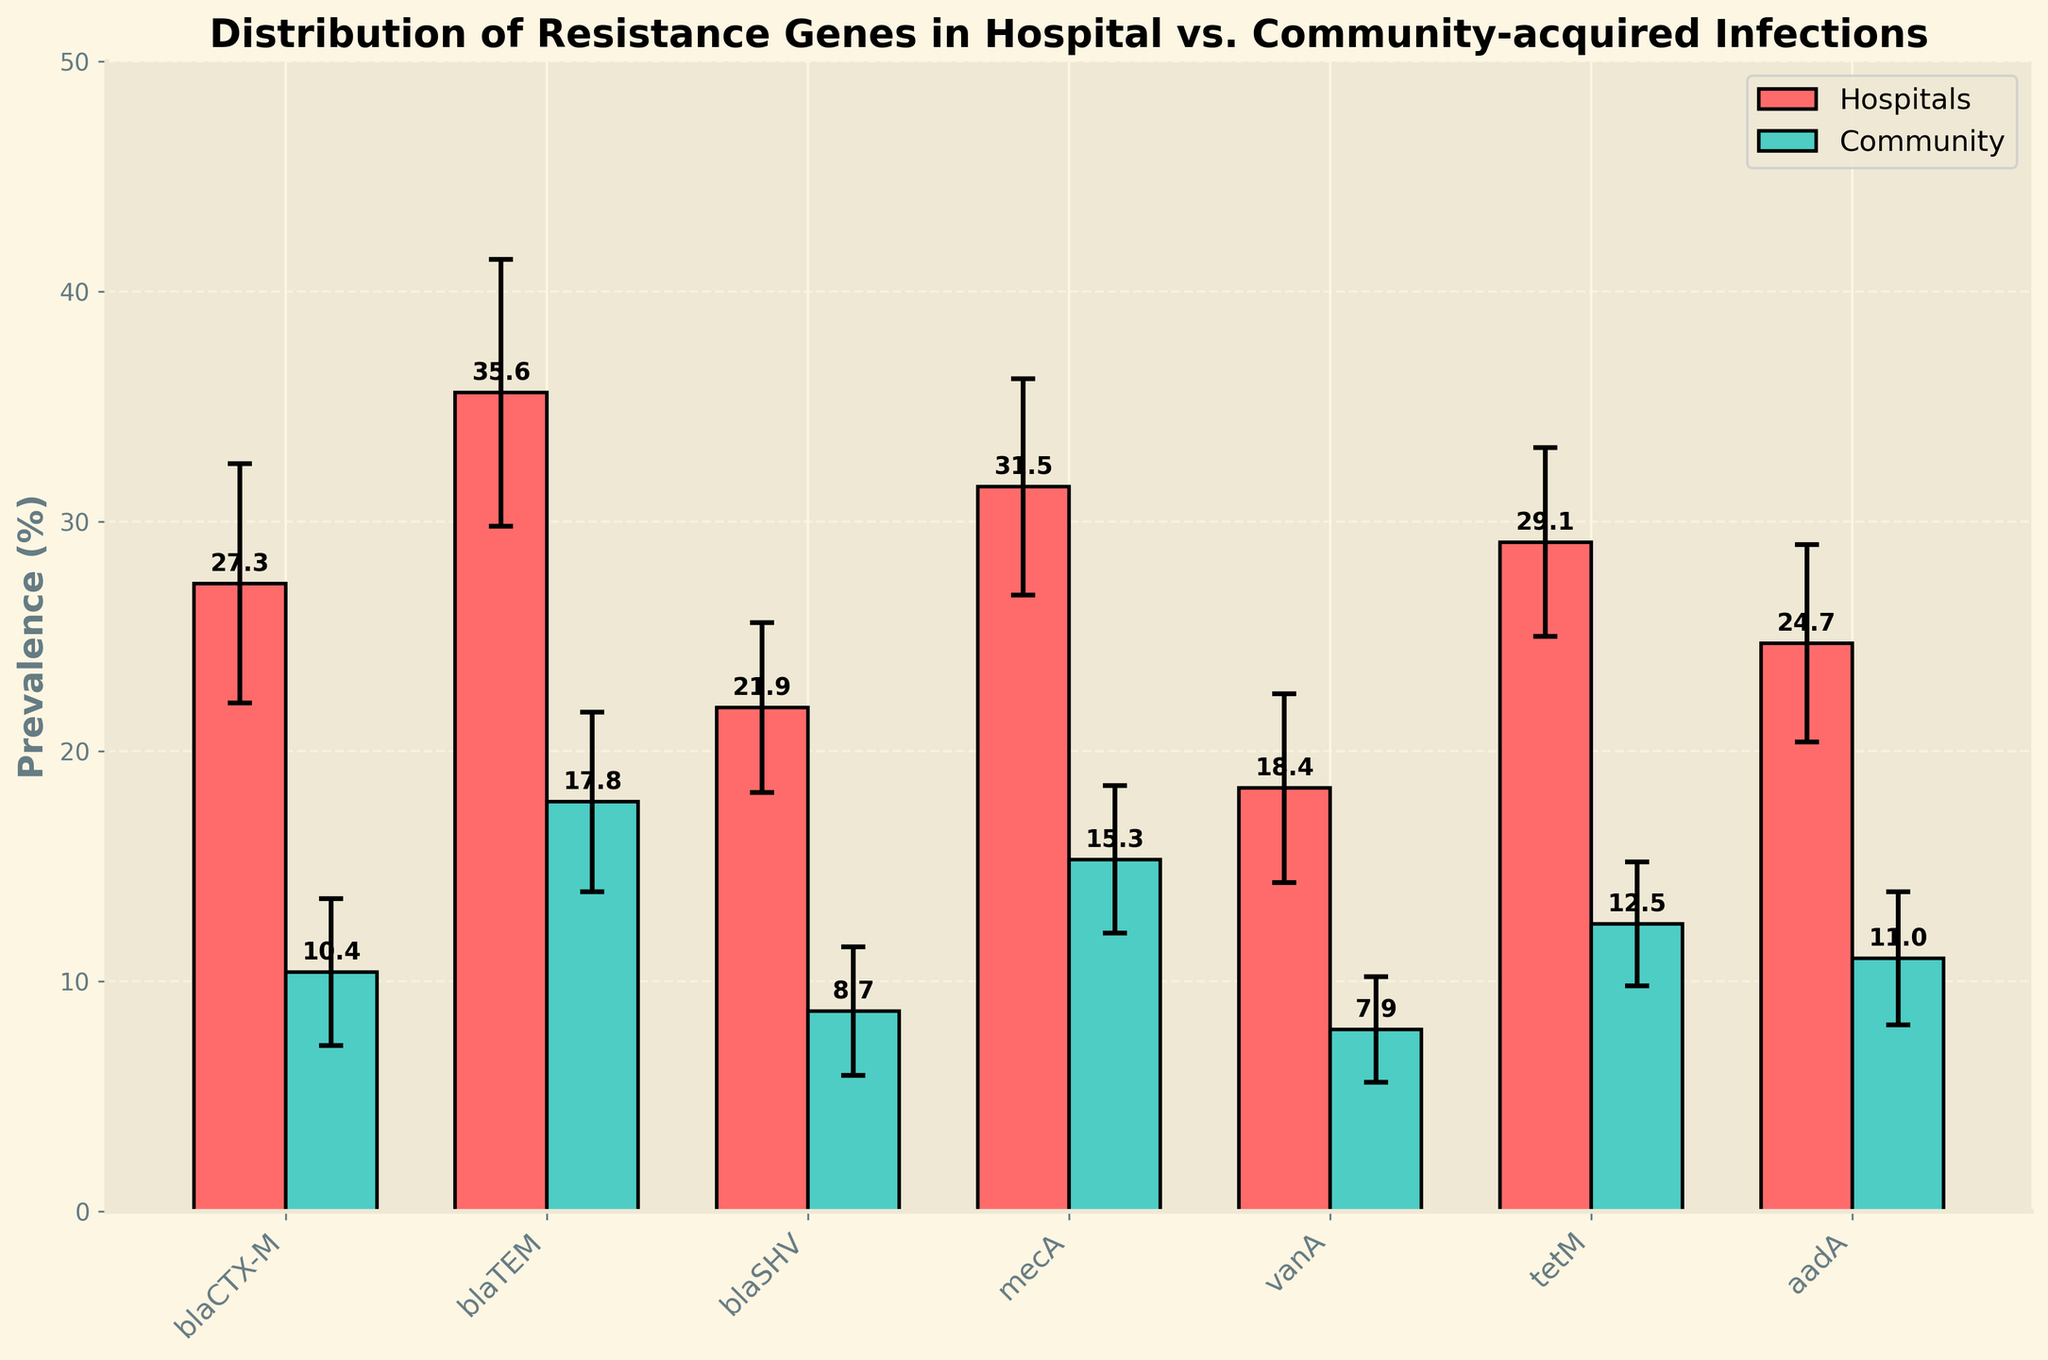What is the title of the figure? The title of the figure is stated prominently at the top of the plot.
Answer: Distribution of Resistance Genes in Hospital vs. Community-acquired Infections What is the difference in prevalence of the blaTEM gene between hospital and community infections? The prevalence of the blaTEM gene in hospital infections is 35.6%, and in community infections, it is 17.8%. The difference is calculated as 35.6% - 17.8%.
Answer: 17.8% Which type of infection shows a higher prevalence of the vanA gene, hospital or community? The prevalence of the vanA gene in hospital infections is 18.4%, whereas in community infections, it is 7.9%. Comparing these prevalences indicates that hospital infections show a higher prevalence.
Answer: Hospital What is the average prevalence of blaCTX-M and tetM genes in hospital infections? The prevalence of the blaCTX-M gene in hospital infections is 27.3%, and the prevalence of the tetM gene is 29.1%. The average is calculated as (27.3 + 29.1) / 2.
Answer: 28.2% Between which two genes does the largest difference in prevalence exist for community-acquired infections? The highest and lowest prevalences among community-acquired infections are 17.8% for blaTEM and 7.9% for vanA. The difference is calculated as 17.8% - 7.9%.
Answer: blaTEM and vanA Which gene exhibits the highest prevalence in hospital-acquired infections? The gene with the highest prevalence in hospital-acquired infections is visibly the tallest bar in the graph corresponding to hospital infections.
Answer: blaTEM For which gene is the confidence interval the widest in community infections? The width of a confidence interval can be determined by subtracting the lower bound from the upper bound. The blaCTX-M gene has a CI ranging from 7.2% to 13.6%, resulting in a width of 13.6% - 7.2%.
Answer: blaCTX-M What is the sum of the prevalences of mecA and aadA genes in community-acquired infections? The prevalences of the mecA and aadA genes in community-acquired infections are 15.3% and 11.0%, respectively. The sum is calculated as 15.3% + 11.0%.
Answer: 26.3% Which gene shows the smallest difference in prevalence between hospital and community-acquired infections? The difference can be calculated for each gene and then compared. For example, for blaCTX-M, the difference is 27.3% - 10.4%. The smallest difference is associated with the gene mecA with a difference of 31.5% - 15.3%.
Answer: mecA 